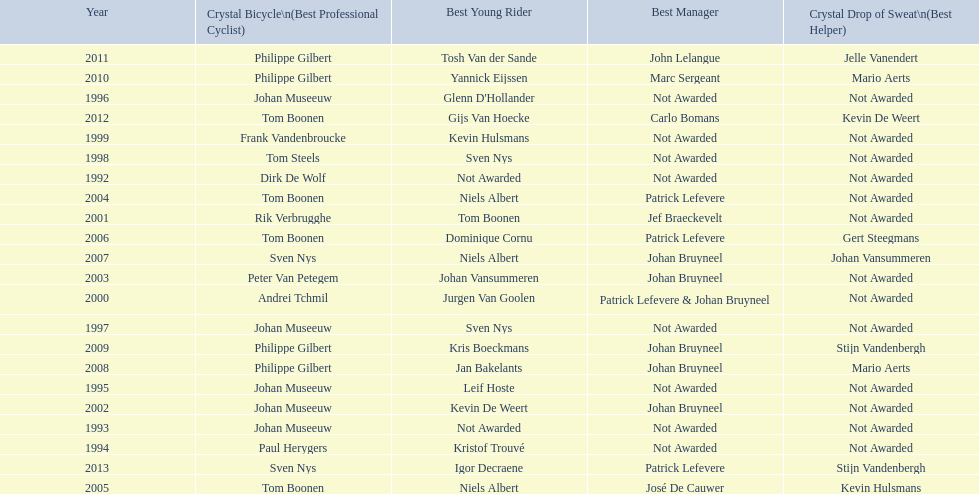Who has won the most best young rider awards? Niels Albert. Could you parse the entire table as a dict? {'header': ['Year', 'Crystal Bicycle\\n(Best Professional Cyclist)', 'Best Young Rider', 'Best Manager', 'Crystal Drop of Sweat\\n(Best Helper)'], 'rows': [['2011', 'Philippe Gilbert', 'Tosh Van der Sande', 'John Lelangue', 'Jelle Vanendert'], ['2010', 'Philippe Gilbert', 'Yannick Eijssen', 'Marc Sergeant', 'Mario Aerts'], ['1996', 'Johan Museeuw', "Glenn D'Hollander", 'Not Awarded', 'Not Awarded'], ['2012', 'Tom Boonen', 'Gijs Van Hoecke', 'Carlo Bomans', 'Kevin De Weert'], ['1999', 'Frank Vandenbroucke', 'Kevin Hulsmans', 'Not Awarded', 'Not Awarded'], ['1998', 'Tom Steels', 'Sven Nys', 'Not Awarded', 'Not Awarded'], ['1992', 'Dirk De Wolf', 'Not Awarded', 'Not Awarded', 'Not Awarded'], ['2004', 'Tom Boonen', 'Niels Albert', 'Patrick Lefevere', 'Not Awarded'], ['2001', 'Rik Verbrugghe', 'Tom Boonen', 'Jef Braeckevelt', 'Not Awarded'], ['2006', 'Tom Boonen', 'Dominique Cornu', 'Patrick Lefevere', 'Gert Steegmans'], ['2007', 'Sven Nys', 'Niels Albert', 'Johan Bruyneel', 'Johan Vansummeren'], ['2003', 'Peter Van Petegem', 'Johan Vansummeren', 'Johan Bruyneel', 'Not Awarded'], ['2000', 'Andrei Tchmil', 'Jurgen Van Goolen', 'Patrick Lefevere & Johan Bruyneel', 'Not Awarded'], ['1997', 'Johan Museeuw', 'Sven Nys', 'Not Awarded', 'Not Awarded'], ['2009', 'Philippe Gilbert', 'Kris Boeckmans', 'Johan Bruyneel', 'Stijn Vandenbergh'], ['2008', 'Philippe Gilbert', 'Jan Bakelants', 'Johan Bruyneel', 'Mario Aerts'], ['1995', 'Johan Museeuw', 'Leif Hoste', 'Not Awarded', 'Not Awarded'], ['2002', 'Johan Museeuw', 'Kevin De Weert', 'Johan Bruyneel', 'Not Awarded'], ['1993', 'Johan Museeuw', 'Not Awarded', 'Not Awarded', 'Not Awarded'], ['1994', 'Paul Herygers', 'Kristof Trouvé', 'Not Awarded', 'Not Awarded'], ['2013', 'Sven Nys', 'Igor Decraene', 'Patrick Lefevere', 'Stijn Vandenbergh'], ['2005', 'Tom Boonen', 'Niels Albert', 'José De Cauwer', 'Kevin Hulsmans']]} 